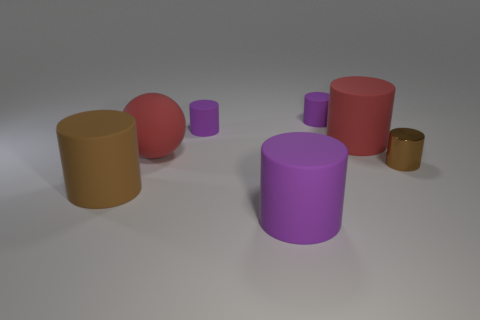Subtract all green blocks. How many purple cylinders are left? 3 Subtract all brown cylinders. How many cylinders are left? 4 Subtract all big red cylinders. How many cylinders are left? 5 Subtract all red cylinders. Subtract all purple balls. How many cylinders are left? 5 Add 1 tiny yellow rubber spheres. How many objects exist? 8 Subtract all cylinders. How many objects are left? 1 Subtract 0 blue spheres. How many objects are left? 7 Subtract all big purple cylinders. Subtract all small purple rubber objects. How many objects are left? 4 Add 6 balls. How many balls are left? 7 Add 7 big balls. How many big balls exist? 8 